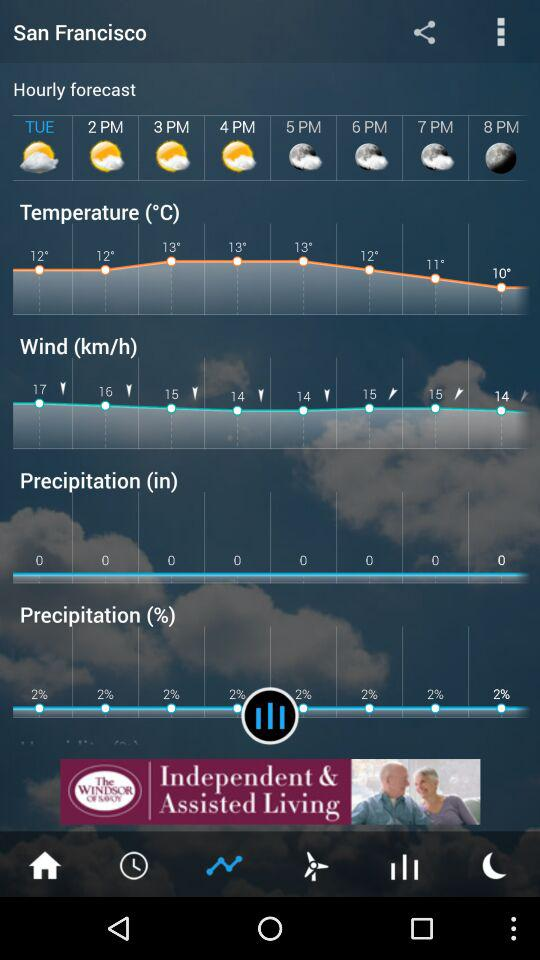What is the maximum temperature?
When the provided information is insufficient, respond with <no answer>. <no answer> 